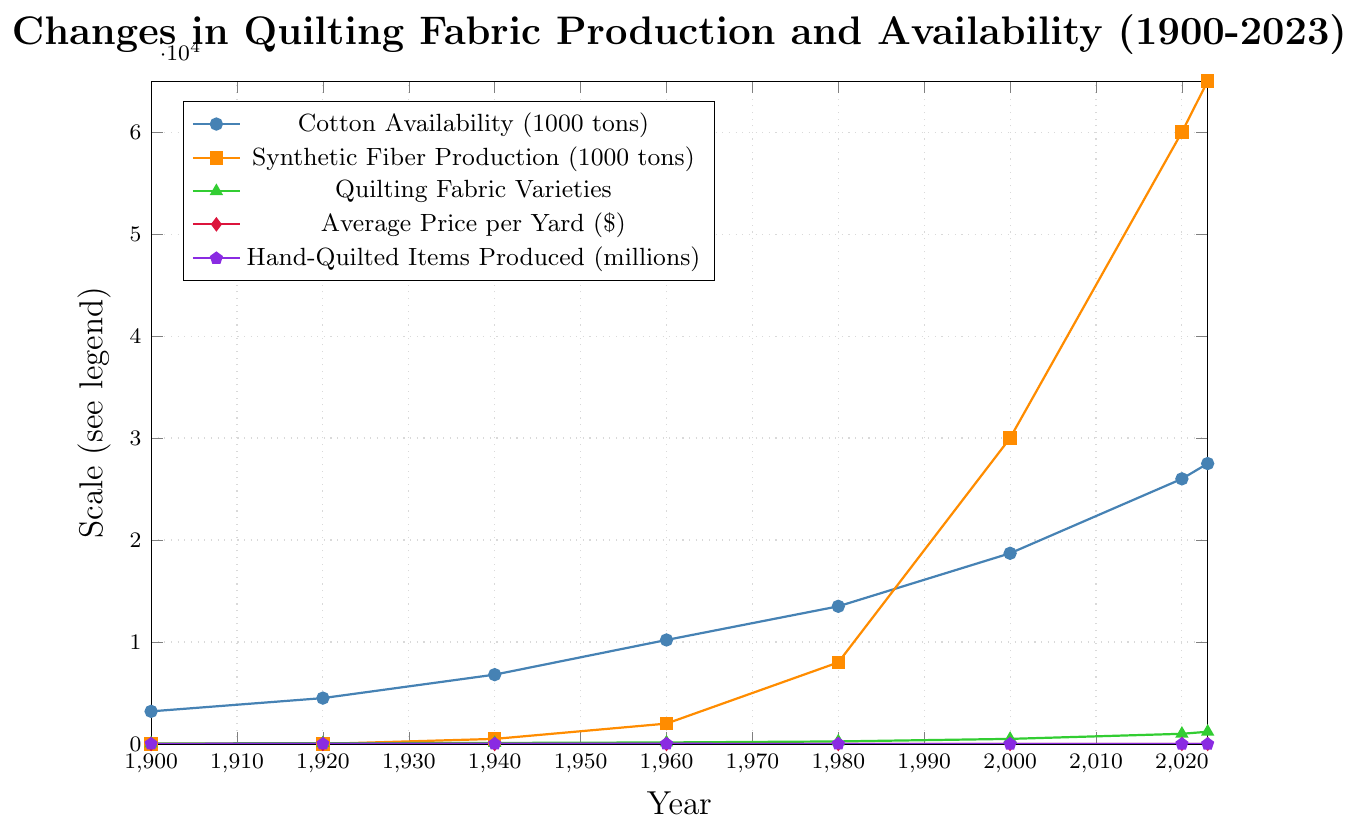What is the trend in cotton availability from 1900 to 2023? Starting at 3,200 thousand tons in 1900, the availability of cotton has shown a generally upward trend, ending at 27,500 thousand tons in 2023.
Answer: Upward What period saw the largest increase in synthetic fiber production? The largest increase in synthetic fiber production occurred between 2000 and 2020, where it increased from 30,000 thousand tons to 60,000 thousand tons.
Answer: 2000 to 2020 How does the availability of quilting fabric varieties correlate with the average price per yard over the years? As the number of quilting fabric varieties increases, the average price per yard also tends to increase. For example, in 1980 there were 250 varieties at $1.50 per yard, and by 2023 there were 1,200 varieties at $9.50 per yard.
Answer: Positive correlation Which had a higher production in 1980, hand-quilted items produced, or synthetic fiber production? In 1980, the production of synthetic fibers was 8,000 thousand tons while hand-quilted items produced were 10 million. Comparing the scales, 8,000 thousand tons is larger than 10 million.
Answer: Synthetic fiber production Calculate the average cotton availability from 1900 to 2023. Summing the values from each year (3,200 + 4,500 + 6,800 + 10,200 + 13,500 + 18,700 + 26,000 + 27,500) gives 110,400. Dividing by the number of data points (8) gives an average of 13,800 thousand tons.
Answer: 13,800 thousand tons What is the change in hand-quilted items produced from 1900 to 2023? In 1900, 12 million hand-quilted items were produced, while in 2023, this number decreased to 1.5 million. The change is 12 - 1.5 = 10.5 million less.
Answer: 10.5 million decrease Which color line represents the average price per yard? The average price per yard is shown with a red line.
Answer: Red Does the variety of quilting fabrics show a faster growth rate compared to synthetic fiber production between 2000 and 2023? Quilting fabric varieties grew from 500 in 2000 to 1,200 in 2023, while synthetic fiber production grew from 30,000 to 65,000. The relative increase for quilting fabric varieties is (1,200-500)/500 = 1.4, or 140%, whereas synthetic fiber production increased by (65,000-30,000)/30,000 = 1.167, or 116.7%. Quilting fabric varieties grew faster in relative terms.
Answer: Yes How many quilting fabric varieties were available in 1940? According to the data, there were 100 quilting fabric varieties available in 1940.
Answer: 100 By what factor has synthetic fiber production increased from 1940 to 2023? Production in 1940 was 500 thousand tons, and in 2023 it was 65,000 thousand tons. The factor of increase is 65,000 / 500 = 130.
Answer: 130 